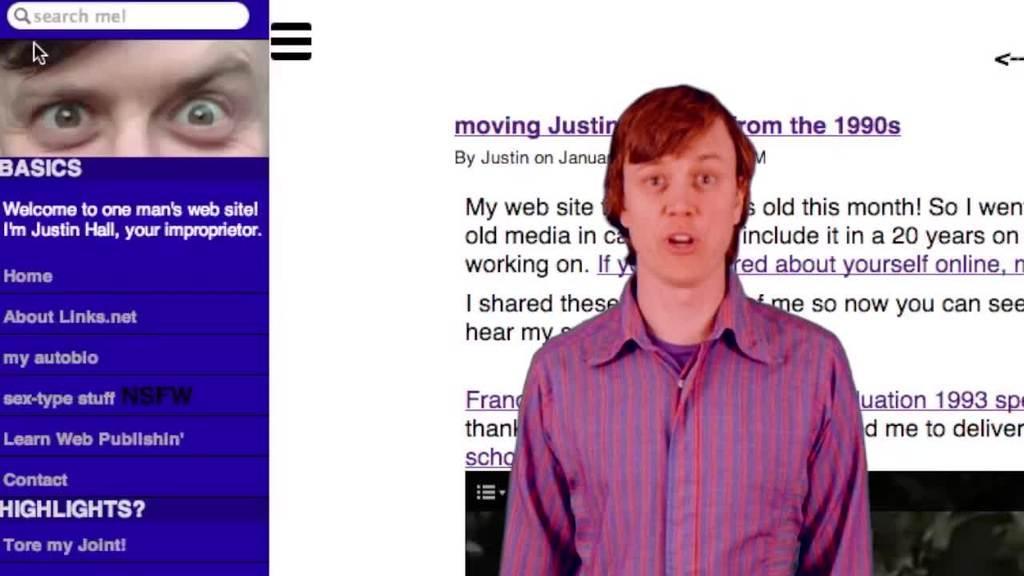Could you give a brief overview of what you see in this image? In this picture we can see a web page, we can see a person in the front, in the background there is some text, on the left side we can see a person's eyes and cursor. 